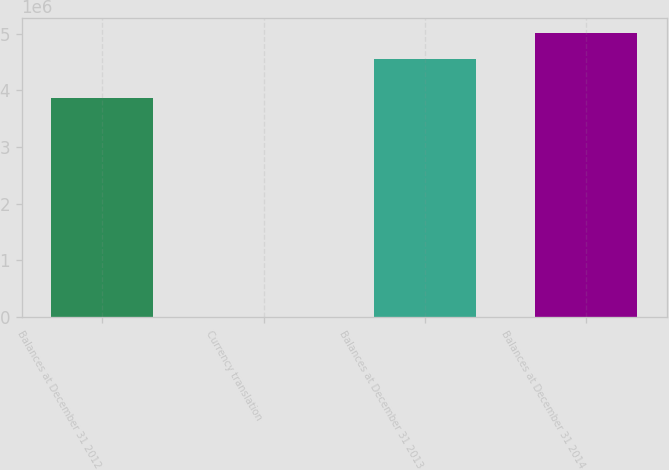<chart> <loc_0><loc_0><loc_500><loc_500><bar_chart><fcel>Balances at December 31 2012<fcel>Currency translation<fcel>Balances at December 31 2013<fcel>Balances at December 31 2014<nl><fcel>3.86886e+06<fcel>9477<fcel>4.55e+06<fcel>5.02012e+06<nl></chart> 